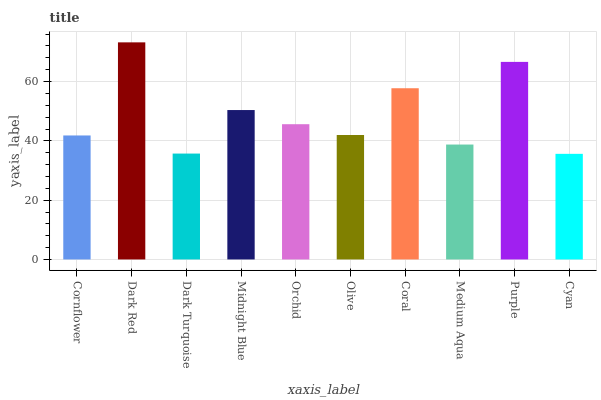Is Cyan the minimum?
Answer yes or no. Yes. Is Dark Red the maximum?
Answer yes or no. Yes. Is Dark Turquoise the minimum?
Answer yes or no. No. Is Dark Turquoise the maximum?
Answer yes or no. No. Is Dark Red greater than Dark Turquoise?
Answer yes or no. Yes. Is Dark Turquoise less than Dark Red?
Answer yes or no. Yes. Is Dark Turquoise greater than Dark Red?
Answer yes or no. No. Is Dark Red less than Dark Turquoise?
Answer yes or no. No. Is Orchid the high median?
Answer yes or no. Yes. Is Olive the low median?
Answer yes or no. Yes. Is Medium Aqua the high median?
Answer yes or no. No. Is Orchid the low median?
Answer yes or no. No. 